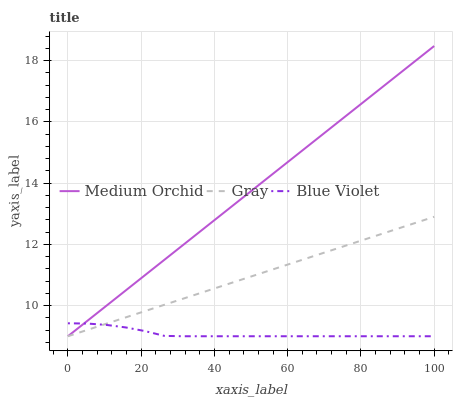Does Blue Violet have the minimum area under the curve?
Answer yes or no. Yes. Does Medium Orchid have the maximum area under the curve?
Answer yes or no. Yes. Does Medium Orchid have the minimum area under the curve?
Answer yes or no. No. Does Blue Violet have the maximum area under the curve?
Answer yes or no. No. Is Gray the smoothest?
Answer yes or no. Yes. Is Blue Violet the roughest?
Answer yes or no. Yes. Is Medium Orchid the smoothest?
Answer yes or no. No. Is Medium Orchid the roughest?
Answer yes or no. No. Does Gray have the lowest value?
Answer yes or no. Yes. Does Medium Orchid have the highest value?
Answer yes or no. Yes. Does Blue Violet have the highest value?
Answer yes or no. No. Does Medium Orchid intersect Gray?
Answer yes or no. Yes. Is Medium Orchid less than Gray?
Answer yes or no. No. Is Medium Orchid greater than Gray?
Answer yes or no. No. 